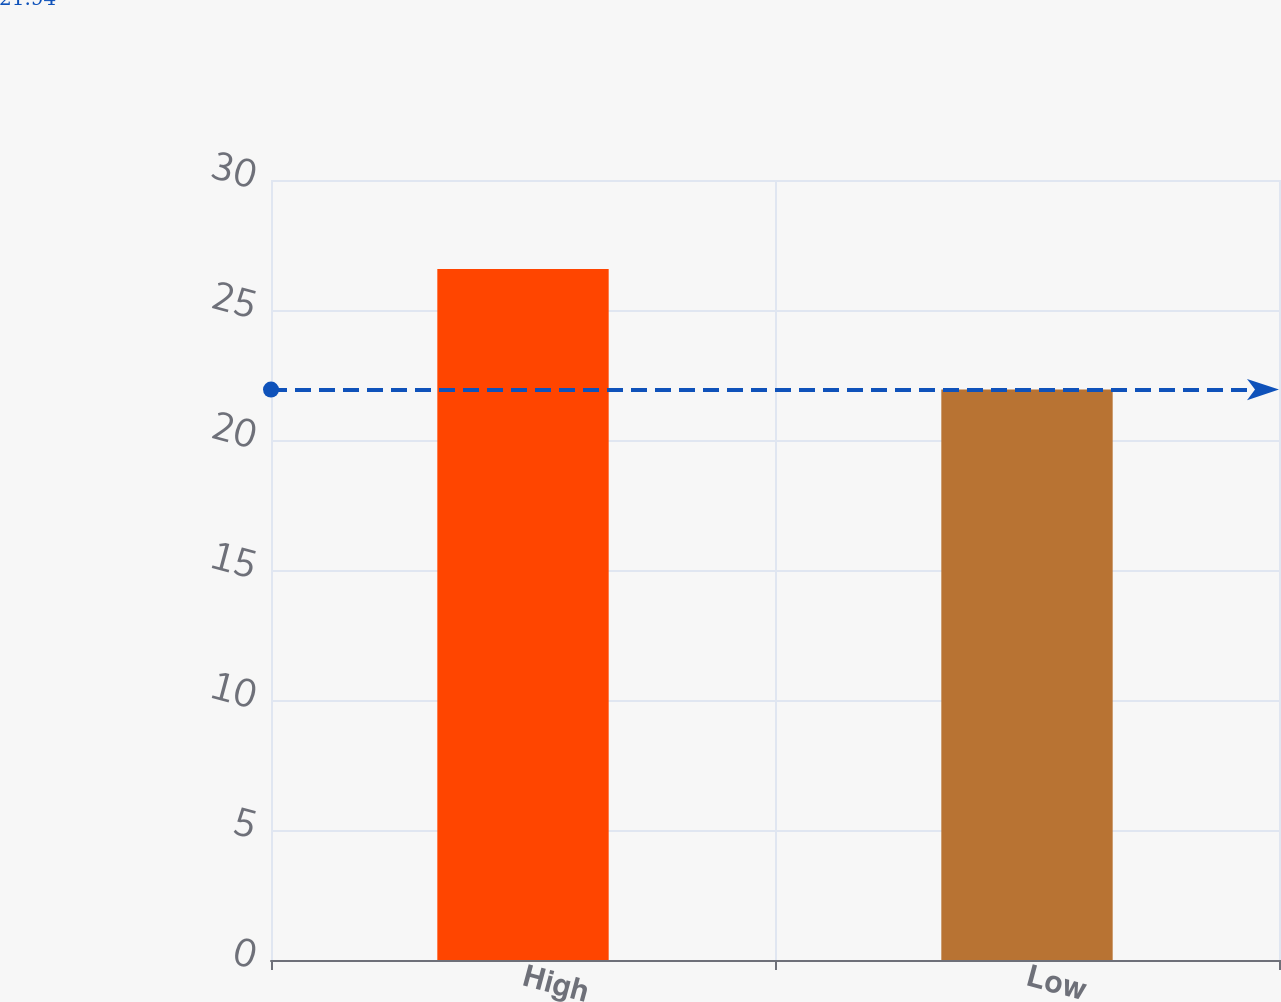<chart> <loc_0><loc_0><loc_500><loc_500><bar_chart><fcel>High<fcel>Low<nl><fcel>26.58<fcel>21.94<nl></chart> 